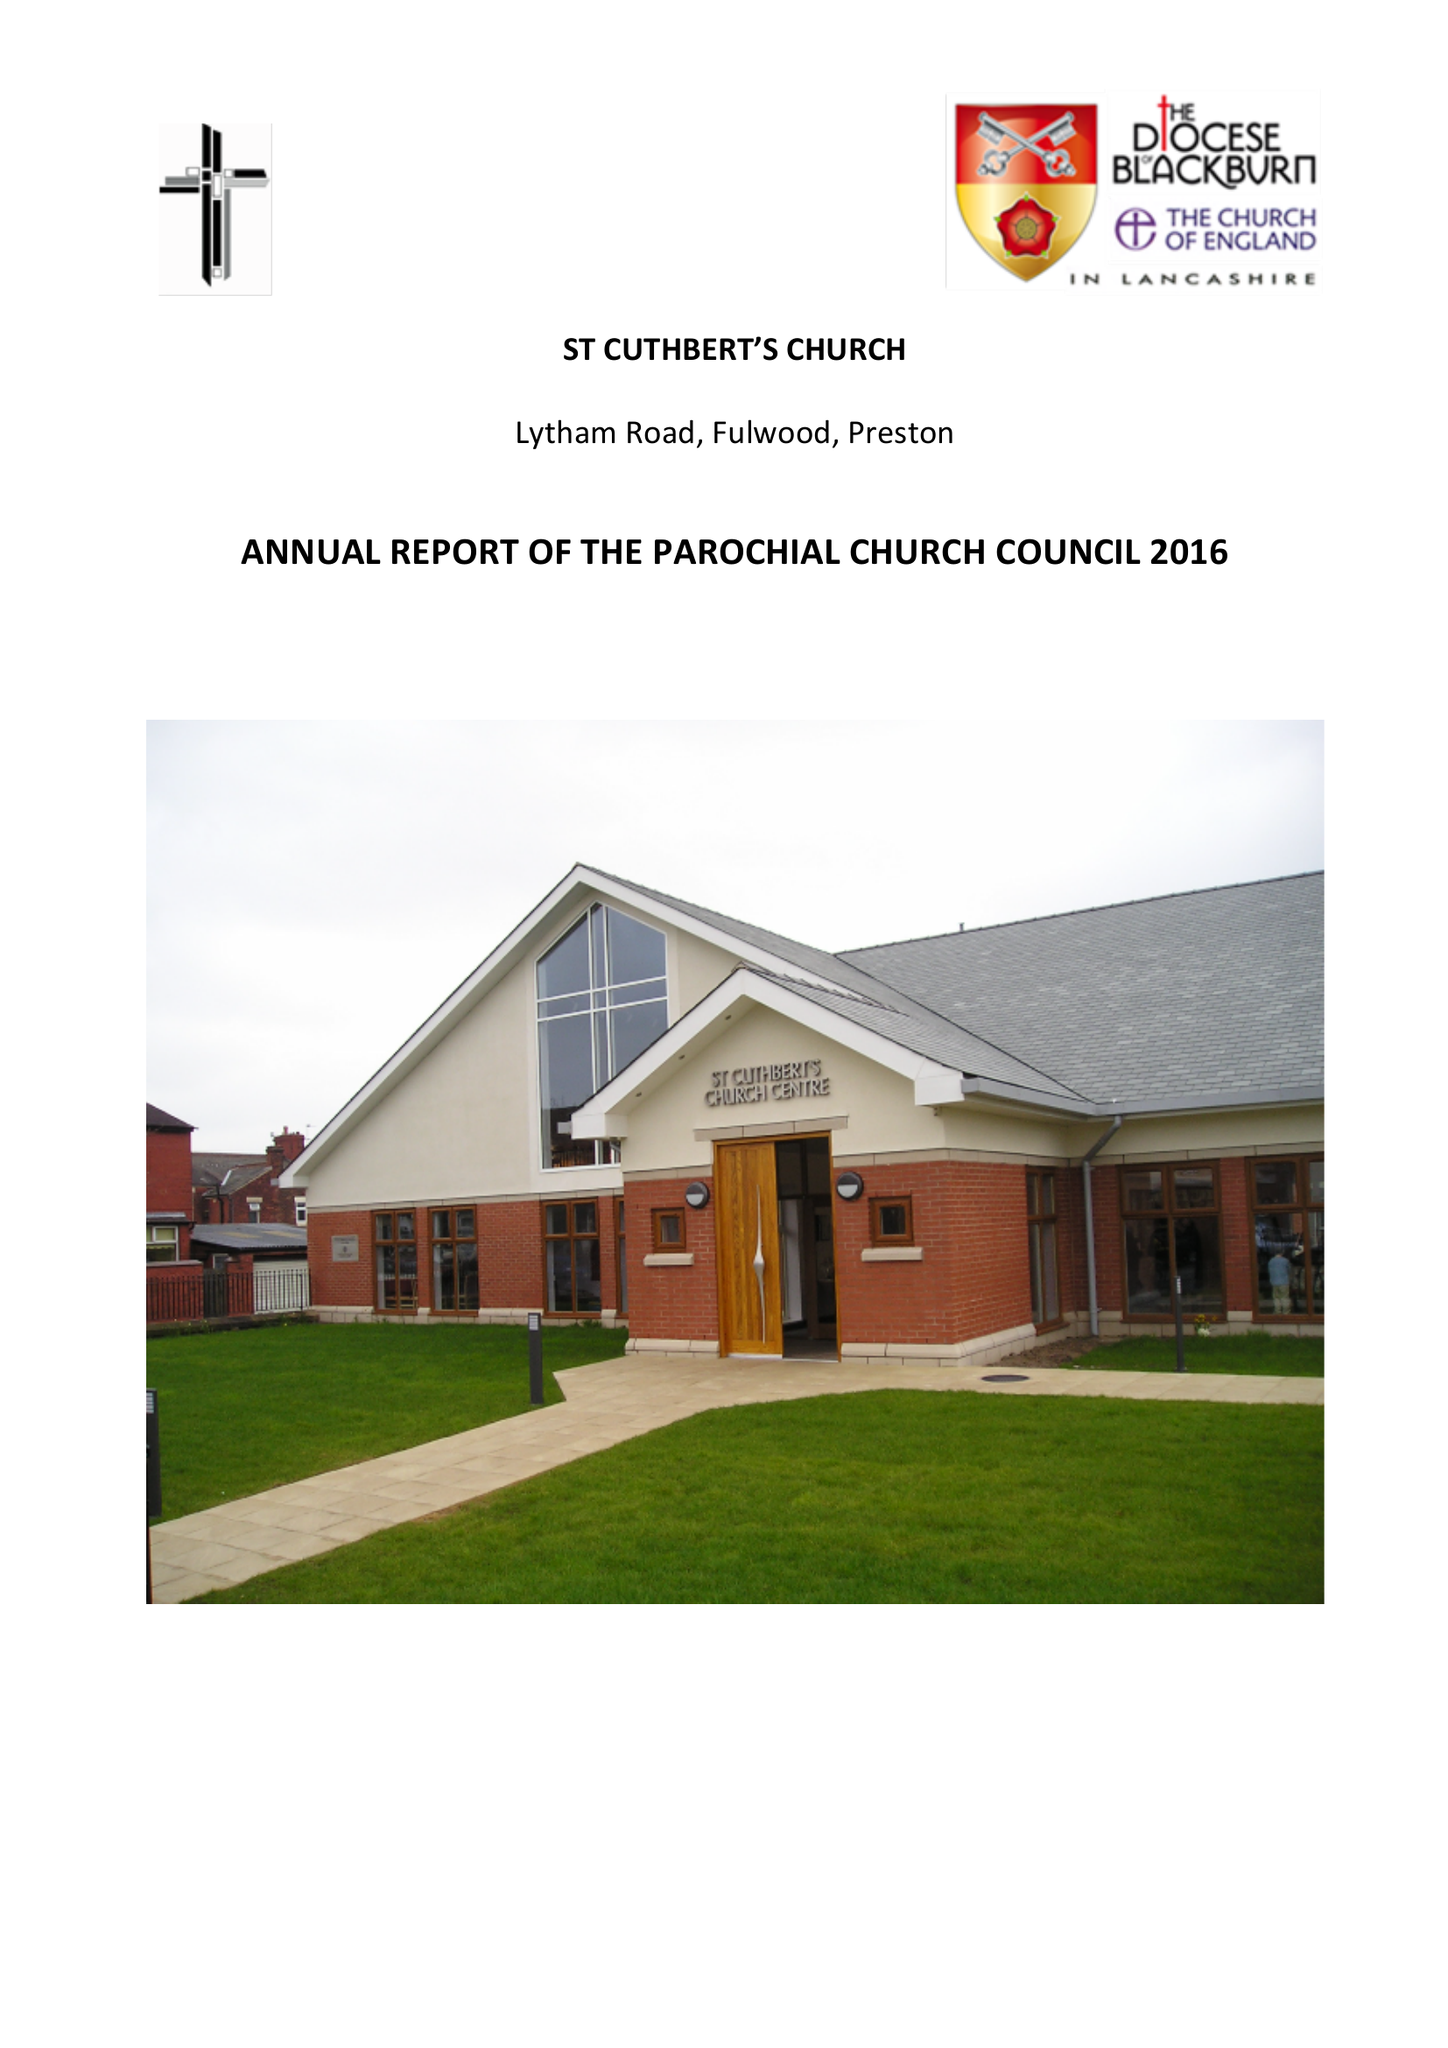What is the value for the report_date?
Answer the question using a single word or phrase. 2016-12-31 